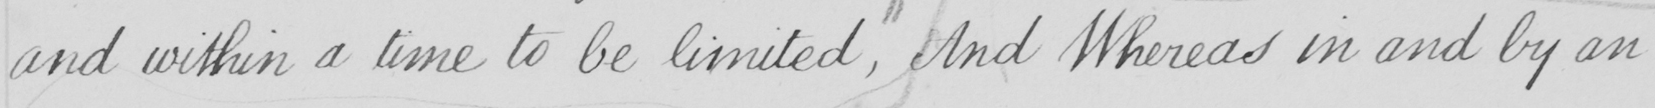What does this handwritten line say? and within a time to be limited , And Whereas in and by an 